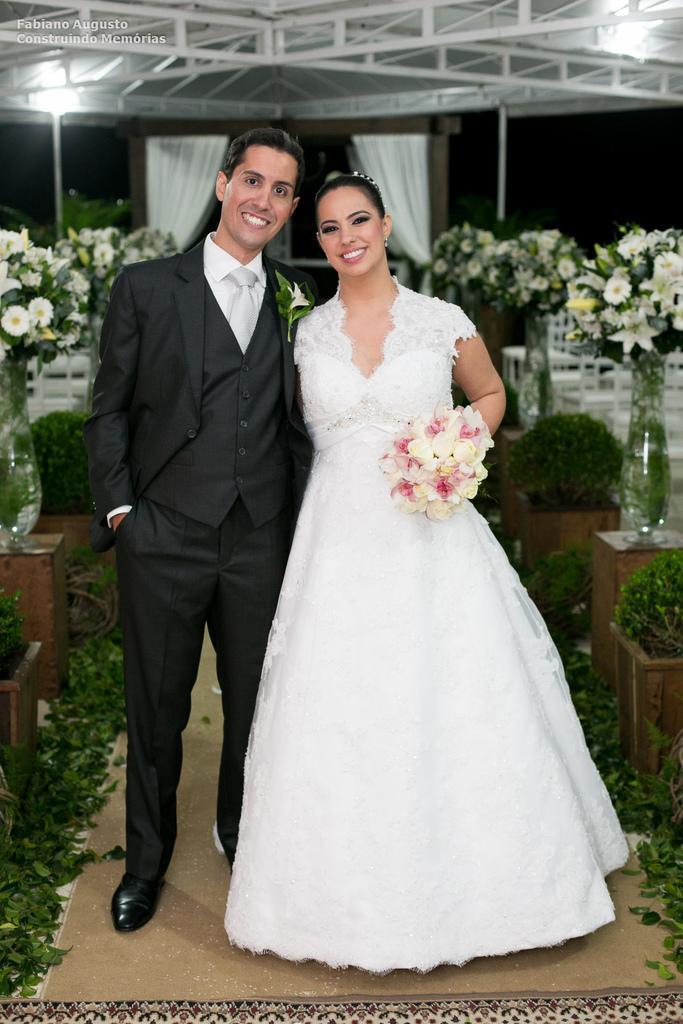Please provide a concise description of this image. In the foreground I can see two persons are standing on the floor. In the background I can see flower vases, houseplants on the tables, tent, lights and a curtain. This image is taken may be during night. 